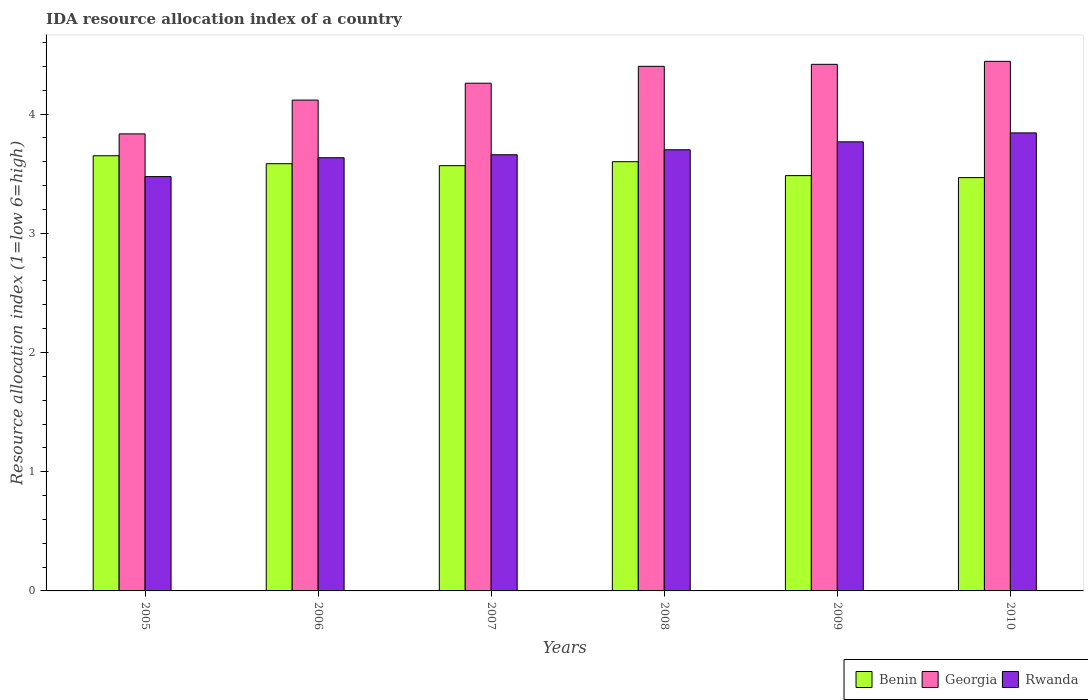How many different coloured bars are there?
Make the answer very short. 3. How many groups of bars are there?
Offer a very short reply. 6. How many bars are there on the 4th tick from the left?
Make the answer very short. 3. What is the label of the 2nd group of bars from the left?
Make the answer very short. 2006. In how many cases, is the number of bars for a given year not equal to the number of legend labels?
Give a very brief answer. 0. What is the IDA resource allocation index in Benin in 2010?
Your answer should be compact. 3.47. Across all years, what is the maximum IDA resource allocation index in Benin?
Make the answer very short. 3.65. Across all years, what is the minimum IDA resource allocation index in Benin?
Offer a very short reply. 3.47. In which year was the IDA resource allocation index in Benin maximum?
Keep it short and to the point. 2005. What is the total IDA resource allocation index in Georgia in the graph?
Make the answer very short. 25.47. What is the difference between the IDA resource allocation index in Georgia in 2006 and that in 2009?
Offer a terse response. -0.3. What is the difference between the IDA resource allocation index in Georgia in 2005 and the IDA resource allocation index in Benin in 2006?
Provide a short and direct response. 0.25. What is the average IDA resource allocation index in Benin per year?
Your answer should be compact. 3.56. In the year 2006, what is the difference between the IDA resource allocation index in Benin and IDA resource allocation index in Georgia?
Your response must be concise. -0.53. In how many years, is the IDA resource allocation index in Rwanda greater than 3.4?
Keep it short and to the point. 6. What is the ratio of the IDA resource allocation index in Georgia in 2007 to that in 2009?
Your response must be concise. 0.96. Is the IDA resource allocation index in Benin in 2009 less than that in 2010?
Your answer should be very brief. No. What is the difference between the highest and the second highest IDA resource allocation index in Rwanda?
Your response must be concise. 0.07. What is the difference between the highest and the lowest IDA resource allocation index in Georgia?
Your answer should be very brief. 0.61. In how many years, is the IDA resource allocation index in Georgia greater than the average IDA resource allocation index in Georgia taken over all years?
Keep it short and to the point. 4. What does the 1st bar from the left in 2010 represents?
Your response must be concise. Benin. What does the 1st bar from the right in 2005 represents?
Your answer should be compact. Rwanda. Is it the case that in every year, the sum of the IDA resource allocation index in Georgia and IDA resource allocation index in Benin is greater than the IDA resource allocation index in Rwanda?
Ensure brevity in your answer.  Yes. How many bars are there?
Give a very brief answer. 18. How many years are there in the graph?
Your answer should be compact. 6. Are the values on the major ticks of Y-axis written in scientific E-notation?
Make the answer very short. No. Does the graph contain any zero values?
Your answer should be very brief. No. Does the graph contain grids?
Ensure brevity in your answer.  No. How many legend labels are there?
Ensure brevity in your answer.  3. What is the title of the graph?
Provide a short and direct response. IDA resource allocation index of a country. Does "Israel" appear as one of the legend labels in the graph?
Keep it short and to the point. No. What is the label or title of the Y-axis?
Offer a terse response. Resource allocation index (1=low 6=high). What is the Resource allocation index (1=low 6=high) of Benin in 2005?
Your answer should be very brief. 3.65. What is the Resource allocation index (1=low 6=high) of Georgia in 2005?
Your response must be concise. 3.83. What is the Resource allocation index (1=low 6=high) of Rwanda in 2005?
Your response must be concise. 3.48. What is the Resource allocation index (1=low 6=high) of Benin in 2006?
Make the answer very short. 3.58. What is the Resource allocation index (1=low 6=high) of Georgia in 2006?
Keep it short and to the point. 4.12. What is the Resource allocation index (1=low 6=high) of Rwanda in 2006?
Provide a succinct answer. 3.63. What is the Resource allocation index (1=low 6=high) of Benin in 2007?
Ensure brevity in your answer.  3.57. What is the Resource allocation index (1=low 6=high) of Georgia in 2007?
Make the answer very short. 4.26. What is the Resource allocation index (1=low 6=high) of Rwanda in 2007?
Make the answer very short. 3.66. What is the Resource allocation index (1=low 6=high) in Benin in 2009?
Keep it short and to the point. 3.48. What is the Resource allocation index (1=low 6=high) of Georgia in 2009?
Offer a terse response. 4.42. What is the Resource allocation index (1=low 6=high) of Rwanda in 2009?
Your answer should be very brief. 3.77. What is the Resource allocation index (1=low 6=high) in Benin in 2010?
Make the answer very short. 3.47. What is the Resource allocation index (1=low 6=high) in Georgia in 2010?
Ensure brevity in your answer.  4.44. What is the Resource allocation index (1=low 6=high) of Rwanda in 2010?
Keep it short and to the point. 3.84. Across all years, what is the maximum Resource allocation index (1=low 6=high) of Benin?
Your answer should be very brief. 3.65. Across all years, what is the maximum Resource allocation index (1=low 6=high) of Georgia?
Make the answer very short. 4.44. Across all years, what is the maximum Resource allocation index (1=low 6=high) in Rwanda?
Offer a very short reply. 3.84. Across all years, what is the minimum Resource allocation index (1=low 6=high) in Benin?
Offer a very short reply. 3.47. Across all years, what is the minimum Resource allocation index (1=low 6=high) in Georgia?
Make the answer very short. 3.83. Across all years, what is the minimum Resource allocation index (1=low 6=high) in Rwanda?
Give a very brief answer. 3.48. What is the total Resource allocation index (1=low 6=high) of Benin in the graph?
Make the answer very short. 21.35. What is the total Resource allocation index (1=low 6=high) in Georgia in the graph?
Make the answer very short. 25.47. What is the total Resource allocation index (1=low 6=high) of Rwanda in the graph?
Your answer should be very brief. 22.07. What is the difference between the Resource allocation index (1=low 6=high) of Benin in 2005 and that in 2006?
Offer a terse response. 0.07. What is the difference between the Resource allocation index (1=low 6=high) in Georgia in 2005 and that in 2006?
Provide a succinct answer. -0.28. What is the difference between the Resource allocation index (1=low 6=high) in Rwanda in 2005 and that in 2006?
Your answer should be very brief. -0.16. What is the difference between the Resource allocation index (1=low 6=high) of Benin in 2005 and that in 2007?
Ensure brevity in your answer.  0.08. What is the difference between the Resource allocation index (1=low 6=high) of Georgia in 2005 and that in 2007?
Offer a very short reply. -0.42. What is the difference between the Resource allocation index (1=low 6=high) of Rwanda in 2005 and that in 2007?
Make the answer very short. -0.18. What is the difference between the Resource allocation index (1=low 6=high) in Georgia in 2005 and that in 2008?
Your response must be concise. -0.57. What is the difference between the Resource allocation index (1=low 6=high) in Rwanda in 2005 and that in 2008?
Keep it short and to the point. -0.23. What is the difference between the Resource allocation index (1=low 6=high) of Georgia in 2005 and that in 2009?
Give a very brief answer. -0.58. What is the difference between the Resource allocation index (1=low 6=high) of Rwanda in 2005 and that in 2009?
Your answer should be compact. -0.29. What is the difference between the Resource allocation index (1=low 6=high) of Benin in 2005 and that in 2010?
Keep it short and to the point. 0.18. What is the difference between the Resource allocation index (1=low 6=high) of Georgia in 2005 and that in 2010?
Ensure brevity in your answer.  -0.61. What is the difference between the Resource allocation index (1=low 6=high) of Rwanda in 2005 and that in 2010?
Keep it short and to the point. -0.37. What is the difference between the Resource allocation index (1=low 6=high) of Benin in 2006 and that in 2007?
Keep it short and to the point. 0.02. What is the difference between the Resource allocation index (1=low 6=high) of Georgia in 2006 and that in 2007?
Provide a short and direct response. -0.14. What is the difference between the Resource allocation index (1=low 6=high) of Rwanda in 2006 and that in 2007?
Offer a terse response. -0.03. What is the difference between the Resource allocation index (1=low 6=high) in Benin in 2006 and that in 2008?
Make the answer very short. -0.02. What is the difference between the Resource allocation index (1=low 6=high) in Georgia in 2006 and that in 2008?
Provide a succinct answer. -0.28. What is the difference between the Resource allocation index (1=low 6=high) of Rwanda in 2006 and that in 2008?
Provide a short and direct response. -0.07. What is the difference between the Resource allocation index (1=low 6=high) in Georgia in 2006 and that in 2009?
Your answer should be compact. -0.3. What is the difference between the Resource allocation index (1=low 6=high) in Rwanda in 2006 and that in 2009?
Make the answer very short. -0.13. What is the difference between the Resource allocation index (1=low 6=high) in Benin in 2006 and that in 2010?
Your answer should be compact. 0.12. What is the difference between the Resource allocation index (1=low 6=high) in Georgia in 2006 and that in 2010?
Provide a succinct answer. -0.33. What is the difference between the Resource allocation index (1=low 6=high) of Rwanda in 2006 and that in 2010?
Your response must be concise. -0.21. What is the difference between the Resource allocation index (1=low 6=high) in Benin in 2007 and that in 2008?
Your answer should be very brief. -0.03. What is the difference between the Resource allocation index (1=low 6=high) of Georgia in 2007 and that in 2008?
Give a very brief answer. -0.14. What is the difference between the Resource allocation index (1=low 6=high) in Rwanda in 2007 and that in 2008?
Provide a short and direct response. -0.04. What is the difference between the Resource allocation index (1=low 6=high) in Benin in 2007 and that in 2009?
Provide a short and direct response. 0.08. What is the difference between the Resource allocation index (1=low 6=high) in Georgia in 2007 and that in 2009?
Your answer should be very brief. -0.16. What is the difference between the Resource allocation index (1=low 6=high) of Rwanda in 2007 and that in 2009?
Offer a terse response. -0.11. What is the difference between the Resource allocation index (1=low 6=high) in Georgia in 2007 and that in 2010?
Offer a terse response. -0.18. What is the difference between the Resource allocation index (1=low 6=high) of Rwanda in 2007 and that in 2010?
Make the answer very short. -0.18. What is the difference between the Resource allocation index (1=low 6=high) of Benin in 2008 and that in 2009?
Your answer should be very brief. 0.12. What is the difference between the Resource allocation index (1=low 6=high) of Georgia in 2008 and that in 2009?
Provide a short and direct response. -0.02. What is the difference between the Resource allocation index (1=low 6=high) in Rwanda in 2008 and that in 2009?
Provide a succinct answer. -0.07. What is the difference between the Resource allocation index (1=low 6=high) of Benin in 2008 and that in 2010?
Your answer should be very brief. 0.13. What is the difference between the Resource allocation index (1=low 6=high) of Georgia in 2008 and that in 2010?
Your answer should be very brief. -0.04. What is the difference between the Resource allocation index (1=low 6=high) of Rwanda in 2008 and that in 2010?
Your answer should be very brief. -0.14. What is the difference between the Resource allocation index (1=low 6=high) of Benin in 2009 and that in 2010?
Keep it short and to the point. 0.02. What is the difference between the Resource allocation index (1=low 6=high) of Georgia in 2009 and that in 2010?
Give a very brief answer. -0.03. What is the difference between the Resource allocation index (1=low 6=high) in Rwanda in 2009 and that in 2010?
Keep it short and to the point. -0.07. What is the difference between the Resource allocation index (1=low 6=high) of Benin in 2005 and the Resource allocation index (1=low 6=high) of Georgia in 2006?
Your answer should be very brief. -0.47. What is the difference between the Resource allocation index (1=low 6=high) in Benin in 2005 and the Resource allocation index (1=low 6=high) in Rwanda in 2006?
Offer a terse response. 0.02. What is the difference between the Resource allocation index (1=low 6=high) of Georgia in 2005 and the Resource allocation index (1=low 6=high) of Rwanda in 2006?
Provide a short and direct response. 0.2. What is the difference between the Resource allocation index (1=low 6=high) of Benin in 2005 and the Resource allocation index (1=low 6=high) of Georgia in 2007?
Your response must be concise. -0.61. What is the difference between the Resource allocation index (1=low 6=high) in Benin in 2005 and the Resource allocation index (1=low 6=high) in Rwanda in 2007?
Offer a terse response. -0.01. What is the difference between the Resource allocation index (1=low 6=high) in Georgia in 2005 and the Resource allocation index (1=low 6=high) in Rwanda in 2007?
Make the answer very short. 0.17. What is the difference between the Resource allocation index (1=low 6=high) in Benin in 2005 and the Resource allocation index (1=low 6=high) in Georgia in 2008?
Provide a succinct answer. -0.75. What is the difference between the Resource allocation index (1=low 6=high) of Benin in 2005 and the Resource allocation index (1=low 6=high) of Rwanda in 2008?
Your response must be concise. -0.05. What is the difference between the Resource allocation index (1=low 6=high) of Georgia in 2005 and the Resource allocation index (1=low 6=high) of Rwanda in 2008?
Give a very brief answer. 0.13. What is the difference between the Resource allocation index (1=low 6=high) of Benin in 2005 and the Resource allocation index (1=low 6=high) of Georgia in 2009?
Your response must be concise. -0.77. What is the difference between the Resource allocation index (1=low 6=high) in Benin in 2005 and the Resource allocation index (1=low 6=high) in Rwanda in 2009?
Your answer should be very brief. -0.12. What is the difference between the Resource allocation index (1=low 6=high) of Georgia in 2005 and the Resource allocation index (1=low 6=high) of Rwanda in 2009?
Provide a short and direct response. 0.07. What is the difference between the Resource allocation index (1=low 6=high) in Benin in 2005 and the Resource allocation index (1=low 6=high) in Georgia in 2010?
Ensure brevity in your answer.  -0.79. What is the difference between the Resource allocation index (1=low 6=high) of Benin in 2005 and the Resource allocation index (1=low 6=high) of Rwanda in 2010?
Your answer should be compact. -0.19. What is the difference between the Resource allocation index (1=low 6=high) of Georgia in 2005 and the Resource allocation index (1=low 6=high) of Rwanda in 2010?
Keep it short and to the point. -0.01. What is the difference between the Resource allocation index (1=low 6=high) of Benin in 2006 and the Resource allocation index (1=low 6=high) of Georgia in 2007?
Offer a very short reply. -0.68. What is the difference between the Resource allocation index (1=low 6=high) of Benin in 2006 and the Resource allocation index (1=low 6=high) of Rwanda in 2007?
Provide a succinct answer. -0.07. What is the difference between the Resource allocation index (1=low 6=high) of Georgia in 2006 and the Resource allocation index (1=low 6=high) of Rwanda in 2007?
Make the answer very short. 0.46. What is the difference between the Resource allocation index (1=low 6=high) in Benin in 2006 and the Resource allocation index (1=low 6=high) in Georgia in 2008?
Give a very brief answer. -0.82. What is the difference between the Resource allocation index (1=low 6=high) in Benin in 2006 and the Resource allocation index (1=low 6=high) in Rwanda in 2008?
Your answer should be very brief. -0.12. What is the difference between the Resource allocation index (1=low 6=high) of Georgia in 2006 and the Resource allocation index (1=low 6=high) of Rwanda in 2008?
Your response must be concise. 0.42. What is the difference between the Resource allocation index (1=low 6=high) of Benin in 2006 and the Resource allocation index (1=low 6=high) of Georgia in 2009?
Give a very brief answer. -0.83. What is the difference between the Resource allocation index (1=low 6=high) of Benin in 2006 and the Resource allocation index (1=low 6=high) of Rwanda in 2009?
Your answer should be compact. -0.18. What is the difference between the Resource allocation index (1=low 6=high) in Georgia in 2006 and the Resource allocation index (1=low 6=high) in Rwanda in 2009?
Your answer should be compact. 0.35. What is the difference between the Resource allocation index (1=low 6=high) of Benin in 2006 and the Resource allocation index (1=low 6=high) of Georgia in 2010?
Offer a very short reply. -0.86. What is the difference between the Resource allocation index (1=low 6=high) in Benin in 2006 and the Resource allocation index (1=low 6=high) in Rwanda in 2010?
Ensure brevity in your answer.  -0.26. What is the difference between the Resource allocation index (1=low 6=high) of Georgia in 2006 and the Resource allocation index (1=low 6=high) of Rwanda in 2010?
Offer a very short reply. 0.28. What is the difference between the Resource allocation index (1=low 6=high) in Benin in 2007 and the Resource allocation index (1=low 6=high) in Georgia in 2008?
Your response must be concise. -0.83. What is the difference between the Resource allocation index (1=low 6=high) of Benin in 2007 and the Resource allocation index (1=low 6=high) of Rwanda in 2008?
Your answer should be very brief. -0.13. What is the difference between the Resource allocation index (1=low 6=high) in Georgia in 2007 and the Resource allocation index (1=low 6=high) in Rwanda in 2008?
Make the answer very short. 0.56. What is the difference between the Resource allocation index (1=low 6=high) of Benin in 2007 and the Resource allocation index (1=low 6=high) of Georgia in 2009?
Your answer should be compact. -0.85. What is the difference between the Resource allocation index (1=low 6=high) in Benin in 2007 and the Resource allocation index (1=low 6=high) in Rwanda in 2009?
Provide a short and direct response. -0.2. What is the difference between the Resource allocation index (1=low 6=high) in Georgia in 2007 and the Resource allocation index (1=low 6=high) in Rwanda in 2009?
Your answer should be very brief. 0.49. What is the difference between the Resource allocation index (1=low 6=high) in Benin in 2007 and the Resource allocation index (1=low 6=high) in Georgia in 2010?
Your answer should be very brief. -0.88. What is the difference between the Resource allocation index (1=low 6=high) of Benin in 2007 and the Resource allocation index (1=low 6=high) of Rwanda in 2010?
Provide a short and direct response. -0.28. What is the difference between the Resource allocation index (1=low 6=high) of Georgia in 2007 and the Resource allocation index (1=low 6=high) of Rwanda in 2010?
Provide a short and direct response. 0.42. What is the difference between the Resource allocation index (1=low 6=high) of Benin in 2008 and the Resource allocation index (1=low 6=high) of Georgia in 2009?
Provide a succinct answer. -0.82. What is the difference between the Resource allocation index (1=low 6=high) in Benin in 2008 and the Resource allocation index (1=low 6=high) in Rwanda in 2009?
Offer a terse response. -0.17. What is the difference between the Resource allocation index (1=low 6=high) of Georgia in 2008 and the Resource allocation index (1=low 6=high) of Rwanda in 2009?
Provide a succinct answer. 0.63. What is the difference between the Resource allocation index (1=low 6=high) of Benin in 2008 and the Resource allocation index (1=low 6=high) of Georgia in 2010?
Provide a short and direct response. -0.84. What is the difference between the Resource allocation index (1=low 6=high) of Benin in 2008 and the Resource allocation index (1=low 6=high) of Rwanda in 2010?
Provide a short and direct response. -0.24. What is the difference between the Resource allocation index (1=low 6=high) of Georgia in 2008 and the Resource allocation index (1=low 6=high) of Rwanda in 2010?
Offer a very short reply. 0.56. What is the difference between the Resource allocation index (1=low 6=high) in Benin in 2009 and the Resource allocation index (1=low 6=high) in Georgia in 2010?
Your answer should be very brief. -0.96. What is the difference between the Resource allocation index (1=low 6=high) in Benin in 2009 and the Resource allocation index (1=low 6=high) in Rwanda in 2010?
Ensure brevity in your answer.  -0.36. What is the difference between the Resource allocation index (1=low 6=high) of Georgia in 2009 and the Resource allocation index (1=low 6=high) of Rwanda in 2010?
Make the answer very short. 0.57. What is the average Resource allocation index (1=low 6=high) of Benin per year?
Provide a succinct answer. 3.56. What is the average Resource allocation index (1=low 6=high) in Georgia per year?
Ensure brevity in your answer.  4.24. What is the average Resource allocation index (1=low 6=high) in Rwanda per year?
Your answer should be compact. 3.68. In the year 2005, what is the difference between the Resource allocation index (1=low 6=high) in Benin and Resource allocation index (1=low 6=high) in Georgia?
Ensure brevity in your answer.  -0.18. In the year 2005, what is the difference between the Resource allocation index (1=low 6=high) in Benin and Resource allocation index (1=low 6=high) in Rwanda?
Your answer should be very brief. 0.17. In the year 2005, what is the difference between the Resource allocation index (1=low 6=high) in Georgia and Resource allocation index (1=low 6=high) in Rwanda?
Offer a very short reply. 0.36. In the year 2006, what is the difference between the Resource allocation index (1=low 6=high) in Benin and Resource allocation index (1=low 6=high) in Georgia?
Provide a short and direct response. -0.53. In the year 2006, what is the difference between the Resource allocation index (1=low 6=high) of Georgia and Resource allocation index (1=low 6=high) of Rwanda?
Keep it short and to the point. 0.48. In the year 2007, what is the difference between the Resource allocation index (1=low 6=high) of Benin and Resource allocation index (1=low 6=high) of Georgia?
Your response must be concise. -0.69. In the year 2007, what is the difference between the Resource allocation index (1=low 6=high) in Benin and Resource allocation index (1=low 6=high) in Rwanda?
Give a very brief answer. -0.09. In the year 2007, what is the difference between the Resource allocation index (1=low 6=high) of Georgia and Resource allocation index (1=low 6=high) of Rwanda?
Provide a succinct answer. 0.6. In the year 2008, what is the difference between the Resource allocation index (1=low 6=high) in Benin and Resource allocation index (1=low 6=high) in Georgia?
Your answer should be compact. -0.8. In the year 2008, what is the difference between the Resource allocation index (1=low 6=high) of Benin and Resource allocation index (1=low 6=high) of Rwanda?
Ensure brevity in your answer.  -0.1. In the year 2009, what is the difference between the Resource allocation index (1=low 6=high) of Benin and Resource allocation index (1=low 6=high) of Georgia?
Your answer should be compact. -0.93. In the year 2009, what is the difference between the Resource allocation index (1=low 6=high) of Benin and Resource allocation index (1=low 6=high) of Rwanda?
Your response must be concise. -0.28. In the year 2009, what is the difference between the Resource allocation index (1=low 6=high) in Georgia and Resource allocation index (1=low 6=high) in Rwanda?
Offer a very short reply. 0.65. In the year 2010, what is the difference between the Resource allocation index (1=low 6=high) of Benin and Resource allocation index (1=low 6=high) of Georgia?
Your answer should be compact. -0.97. In the year 2010, what is the difference between the Resource allocation index (1=low 6=high) in Benin and Resource allocation index (1=low 6=high) in Rwanda?
Provide a succinct answer. -0.38. In the year 2010, what is the difference between the Resource allocation index (1=low 6=high) in Georgia and Resource allocation index (1=low 6=high) in Rwanda?
Offer a very short reply. 0.6. What is the ratio of the Resource allocation index (1=low 6=high) in Benin in 2005 to that in 2006?
Keep it short and to the point. 1.02. What is the ratio of the Resource allocation index (1=low 6=high) in Georgia in 2005 to that in 2006?
Offer a very short reply. 0.93. What is the ratio of the Resource allocation index (1=low 6=high) in Rwanda in 2005 to that in 2006?
Your response must be concise. 0.96. What is the ratio of the Resource allocation index (1=low 6=high) of Benin in 2005 to that in 2007?
Give a very brief answer. 1.02. What is the ratio of the Resource allocation index (1=low 6=high) in Georgia in 2005 to that in 2007?
Ensure brevity in your answer.  0.9. What is the ratio of the Resource allocation index (1=low 6=high) of Rwanda in 2005 to that in 2007?
Ensure brevity in your answer.  0.95. What is the ratio of the Resource allocation index (1=low 6=high) in Benin in 2005 to that in 2008?
Ensure brevity in your answer.  1.01. What is the ratio of the Resource allocation index (1=low 6=high) in Georgia in 2005 to that in 2008?
Give a very brief answer. 0.87. What is the ratio of the Resource allocation index (1=low 6=high) in Rwanda in 2005 to that in 2008?
Your answer should be compact. 0.94. What is the ratio of the Resource allocation index (1=low 6=high) in Benin in 2005 to that in 2009?
Your answer should be compact. 1.05. What is the ratio of the Resource allocation index (1=low 6=high) of Georgia in 2005 to that in 2009?
Your response must be concise. 0.87. What is the ratio of the Resource allocation index (1=low 6=high) of Rwanda in 2005 to that in 2009?
Give a very brief answer. 0.92. What is the ratio of the Resource allocation index (1=low 6=high) in Benin in 2005 to that in 2010?
Your response must be concise. 1.05. What is the ratio of the Resource allocation index (1=low 6=high) in Georgia in 2005 to that in 2010?
Make the answer very short. 0.86. What is the ratio of the Resource allocation index (1=low 6=high) in Rwanda in 2005 to that in 2010?
Offer a terse response. 0.9. What is the ratio of the Resource allocation index (1=low 6=high) of Benin in 2006 to that in 2007?
Make the answer very short. 1. What is the ratio of the Resource allocation index (1=low 6=high) in Georgia in 2006 to that in 2007?
Provide a succinct answer. 0.97. What is the ratio of the Resource allocation index (1=low 6=high) in Rwanda in 2006 to that in 2007?
Your answer should be very brief. 0.99. What is the ratio of the Resource allocation index (1=low 6=high) in Georgia in 2006 to that in 2008?
Give a very brief answer. 0.94. What is the ratio of the Resource allocation index (1=low 6=high) of Benin in 2006 to that in 2009?
Your answer should be very brief. 1.03. What is the ratio of the Resource allocation index (1=low 6=high) in Georgia in 2006 to that in 2009?
Your answer should be compact. 0.93. What is the ratio of the Resource allocation index (1=low 6=high) in Rwanda in 2006 to that in 2009?
Offer a terse response. 0.96. What is the ratio of the Resource allocation index (1=low 6=high) in Benin in 2006 to that in 2010?
Your response must be concise. 1.03. What is the ratio of the Resource allocation index (1=low 6=high) of Georgia in 2006 to that in 2010?
Keep it short and to the point. 0.93. What is the ratio of the Resource allocation index (1=low 6=high) in Rwanda in 2006 to that in 2010?
Ensure brevity in your answer.  0.95. What is the ratio of the Resource allocation index (1=low 6=high) of Georgia in 2007 to that in 2008?
Keep it short and to the point. 0.97. What is the ratio of the Resource allocation index (1=low 6=high) of Rwanda in 2007 to that in 2008?
Your answer should be compact. 0.99. What is the ratio of the Resource allocation index (1=low 6=high) in Benin in 2007 to that in 2009?
Your answer should be very brief. 1.02. What is the ratio of the Resource allocation index (1=low 6=high) of Georgia in 2007 to that in 2009?
Offer a very short reply. 0.96. What is the ratio of the Resource allocation index (1=low 6=high) in Rwanda in 2007 to that in 2009?
Your answer should be compact. 0.97. What is the ratio of the Resource allocation index (1=low 6=high) in Benin in 2007 to that in 2010?
Ensure brevity in your answer.  1.03. What is the ratio of the Resource allocation index (1=low 6=high) in Georgia in 2007 to that in 2010?
Offer a very short reply. 0.96. What is the ratio of the Resource allocation index (1=low 6=high) in Rwanda in 2007 to that in 2010?
Offer a very short reply. 0.95. What is the ratio of the Resource allocation index (1=low 6=high) of Benin in 2008 to that in 2009?
Ensure brevity in your answer.  1.03. What is the ratio of the Resource allocation index (1=low 6=high) of Georgia in 2008 to that in 2009?
Your answer should be very brief. 1. What is the ratio of the Resource allocation index (1=low 6=high) of Rwanda in 2008 to that in 2009?
Your response must be concise. 0.98. What is the ratio of the Resource allocation index (1=low 6=high) in Georgia in 2008 to that in 2010?
Your response must be concise. 0.99. What is the ratio of the Resource allocation index (1=low 6=high) of Rwanda in 2008 to that in 2010?
Keep it short and to the point. 0.96. What is the ratio of the Resource allocation index (1=low 6=high) of Benin in 2009 to that in 2010?
Keep it short and to the point. 1. What is the ratio of the Resource allocation index (1=low 6=high) in Rwanda in 2009 to that in 2010?
Your answer should be compact. 0.98. What is the difference between the highest and the second highest Resource allocation index (1=low 6=high) of Georgia?
Keep it short and to the point. 0.03. What is the difference between the highest and the second highest Resource allocation index (1=low 6=high) of Rwanda?
Provide a short and direct response. 0.07. What is the difference between the highest and the lowest Resource allocation index (1=low 6=high) in Benin?
Your answer should be compact. 0.18. What is the difference between the highest and the lowest Resource allocation index (1=low 6=high) in Georgia?
Give a very brief answer. 0.61. What is the difference between the highest and the lowest Resource allocation index (1=low 6=high) of Rwanda?
Your response must be concise. 0.37. 